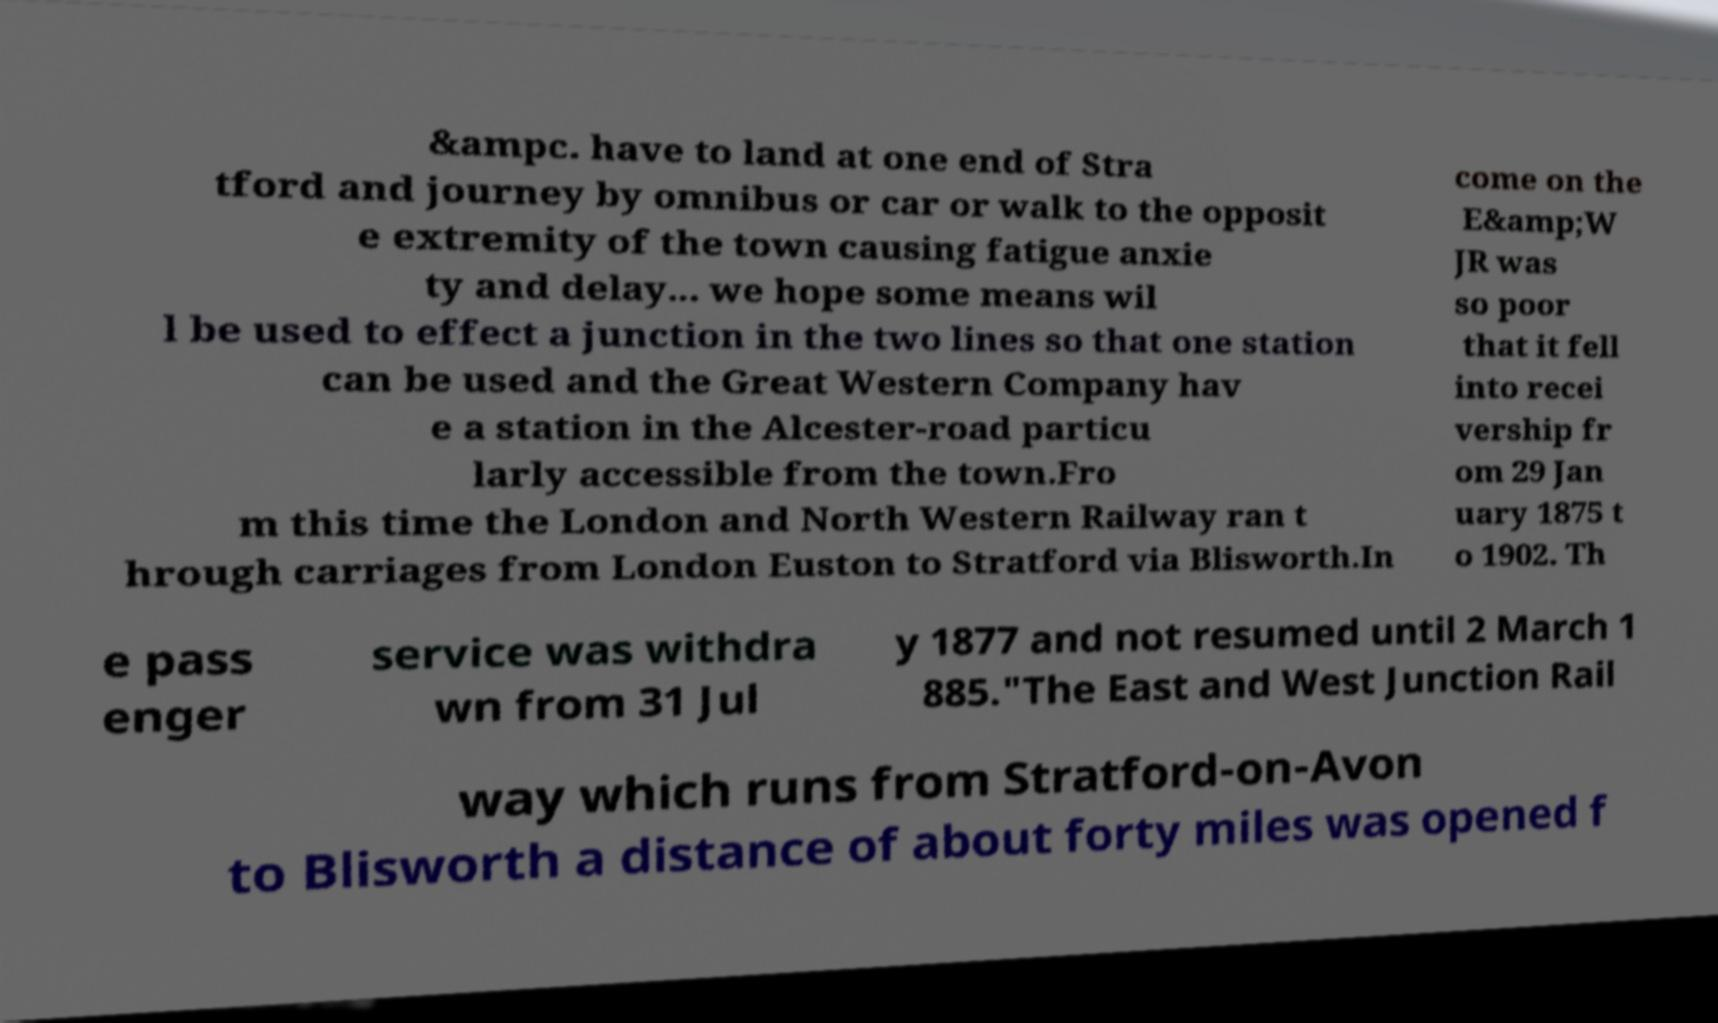I need the written content from this picture converted into text. Can you do that? &ampc. have to land at one end of Stra tford and journey by omnibus or car or walk to the opposit e extremity of the town causing fatigue anxie ty and delay... we hope some means wil l be used to effect a junction in the two lines so that one station can be used and the Great Western Company hav e a station in the Alcester-road particu larly accessible from the town.Fro m this time the London and North Western Railway ran t hrough carriages from London Euston to Stratford via Blisworth.In come on the E&amp;W JR was so poor that it fell into recei vership fr om 29 Jan uary 1875 t o 1902. Th e pass enger service was withdra wn from 31 Jul y 1877 and not resumed until 2 March 1 885."The East and West Junction Rail way which runs from Stratford-on-Avon to Blisworth a distance of about forty miles was opened f 